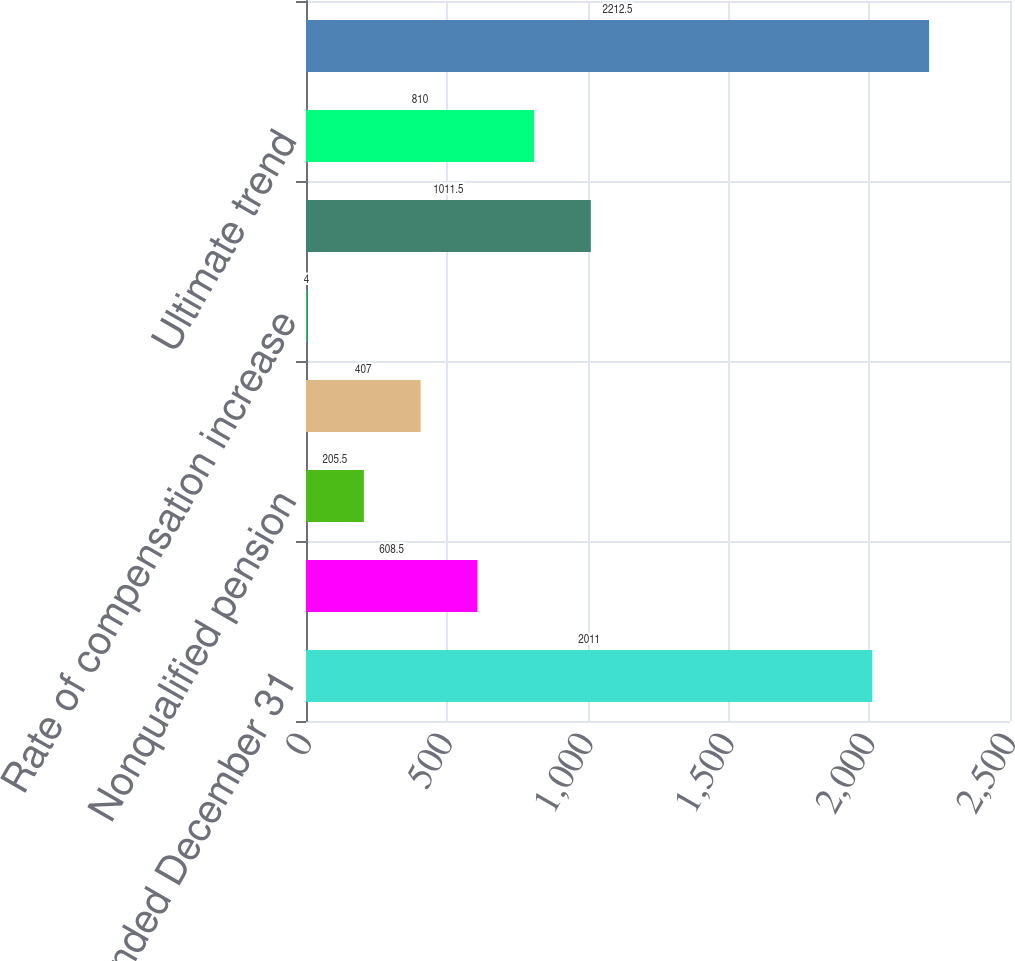Convert chart to OTSL. <chart><loc_0><loc_0><loc_500><loc_500><bar_chart><fcel>Year ended December 31<fcel>Qualified pension<fcel>Nonqualified pension<fcel>Postretirement benefits<fcel>Rate of compensation increase<fcel>Initial trend<fcel>Ultimate trend<fcel>Year ultimate reached<nl><fcel>2011<fcel>608.5<fcel>205.5<fcel>407<fcel>4<fcel>1011.5<fcel>810<fcel>2212.5<nl></chart> 